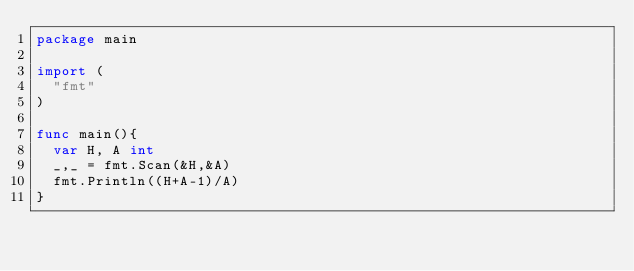Convert code to text. <code><loc_0><loc_0><loc_500><loc_500><_Go_>package main

import (
	"fmt"
)

func main(){
	var H, A int
	_,_ = fmt.Scan(&H,&A)
	fmt.Println((H+A-1)/A)
}</code> 